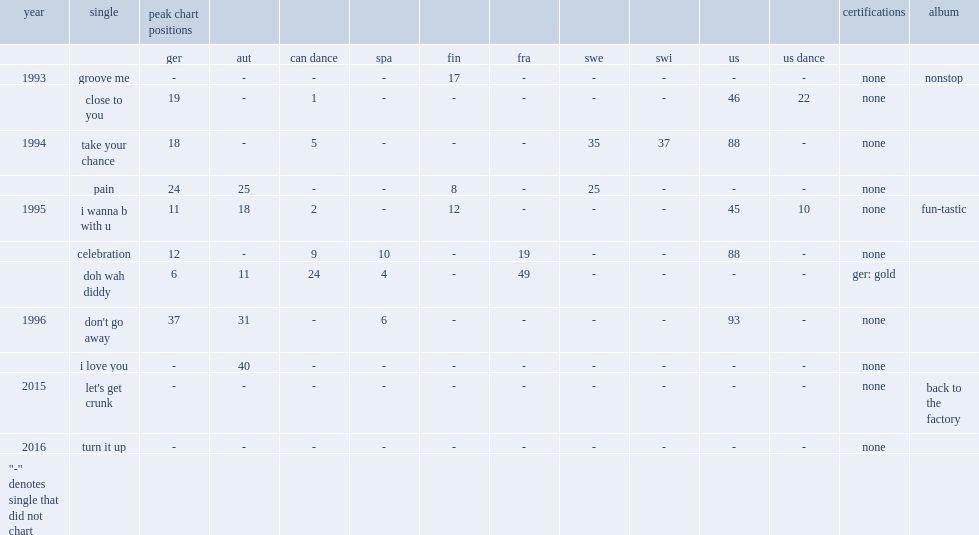When did fun factory make the single "let's get crunk" of album "back to the factory"? 2015.0. 